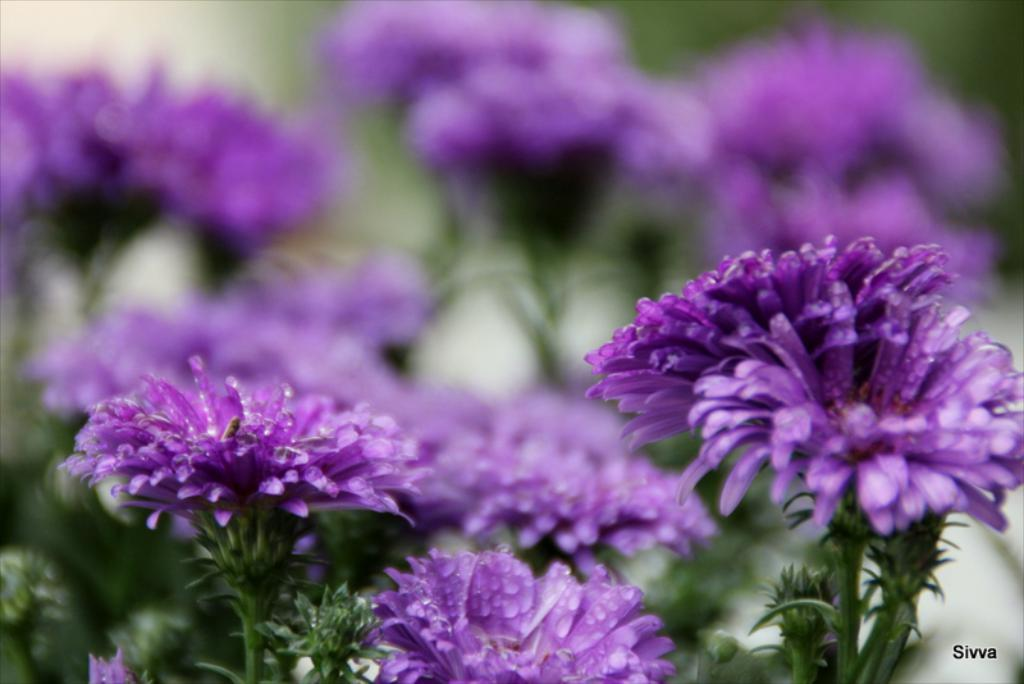What type of living organisms can be seen in the image? There are flowers in the image. Where are the flowers located? The flowers are on plants. What color are the flowers? The flowers are purple in color. What type of bread can be seen in the image? There is no bread present in the image; it features flowers on plants. 